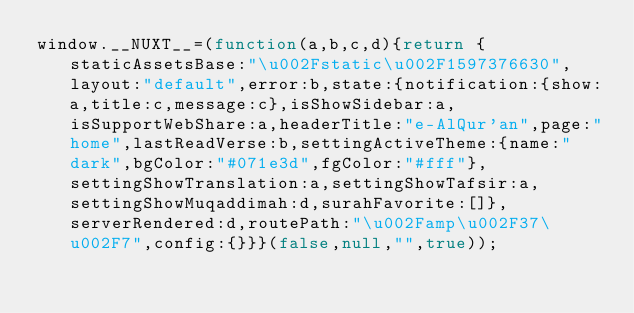<code> <loc_0><loc_0><loc_500><loc_500><_JavaScript_>window.__NUXT__=(function(a,b,c,d){return {staticAssetsBase:"\u002Fstatic\u002F1597376630",layout:"default",error:b,state:{notification:{show:a,title:c,message:c},isShowSidebar:a,isSupportWebShare:a,headerTitle:"e-AlQur'an",page:"home",lastReadVerse:b,settingActiveTheme:{name:"dark",bgColor:"#071e3d",fgColor:"#fff"},settingShowTranslation:a,settingShowTafsir:a,settingShowMuqaddimah:d,surahFavorite:[]},serverRendered:d,routePath:"\u002Famp\u002F37\u002F7",config:{}}}(false,null,"",true));</code> 